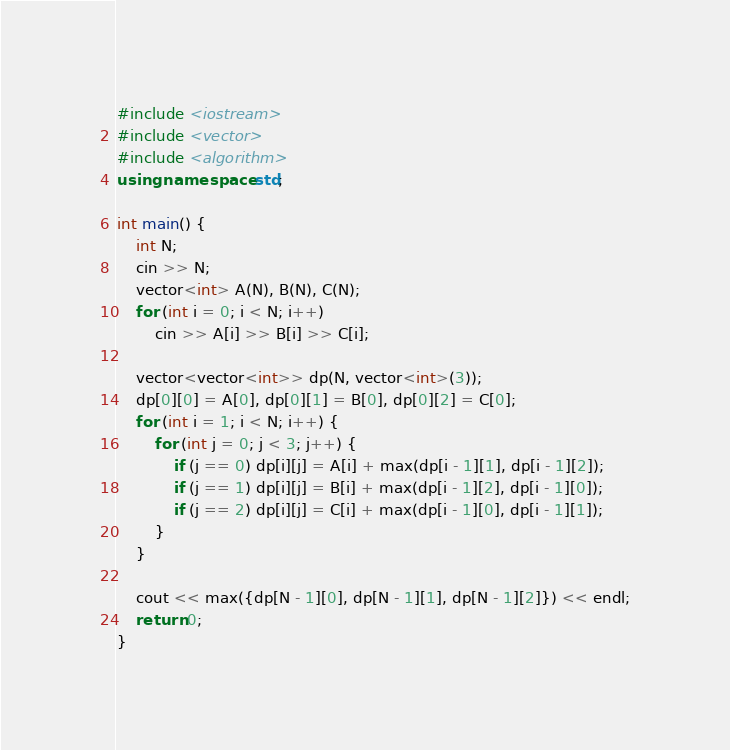<code> <loc_0><loc_0><loc_500><loc_500><_C++_>#include <iostream>
#include <vector>
#include <algorithm>
using namespace std;

int main() {
    int N;
    cin >> N;
    vector<int> A(N), B(N), C(N);
    for (int i = 0; i < N; i++)
        cin >> A[i] >> B[i] >> C[i];

    vector<vector<int>> dp(N, vector<int>(3));
    dp[0][0] = A[0], dp[0][1] = B[0], dp[0][2] = C[0];
    for (int i = 1; i < N; i++) {
        for (int j = 0; j < 3; j++) {
            if (j == 0) dp[i][j] = A[i] + max(dp[i - 1][1], dp[i - 1][2]);
            if (j == 1) dp[i][j] = B[i] + max(dp[i - 1][2], dp[i - 1][0]);
            if (j == 2) dp[i][j] = C[i] + max(dp[i - 1][0], dp[i - 1][1]);
        }
    }

    cout << max({dp[N - 1][0], dp[N - 1][1], dp[N - 1][2]}) << endl;
    return 0;
}</code> 